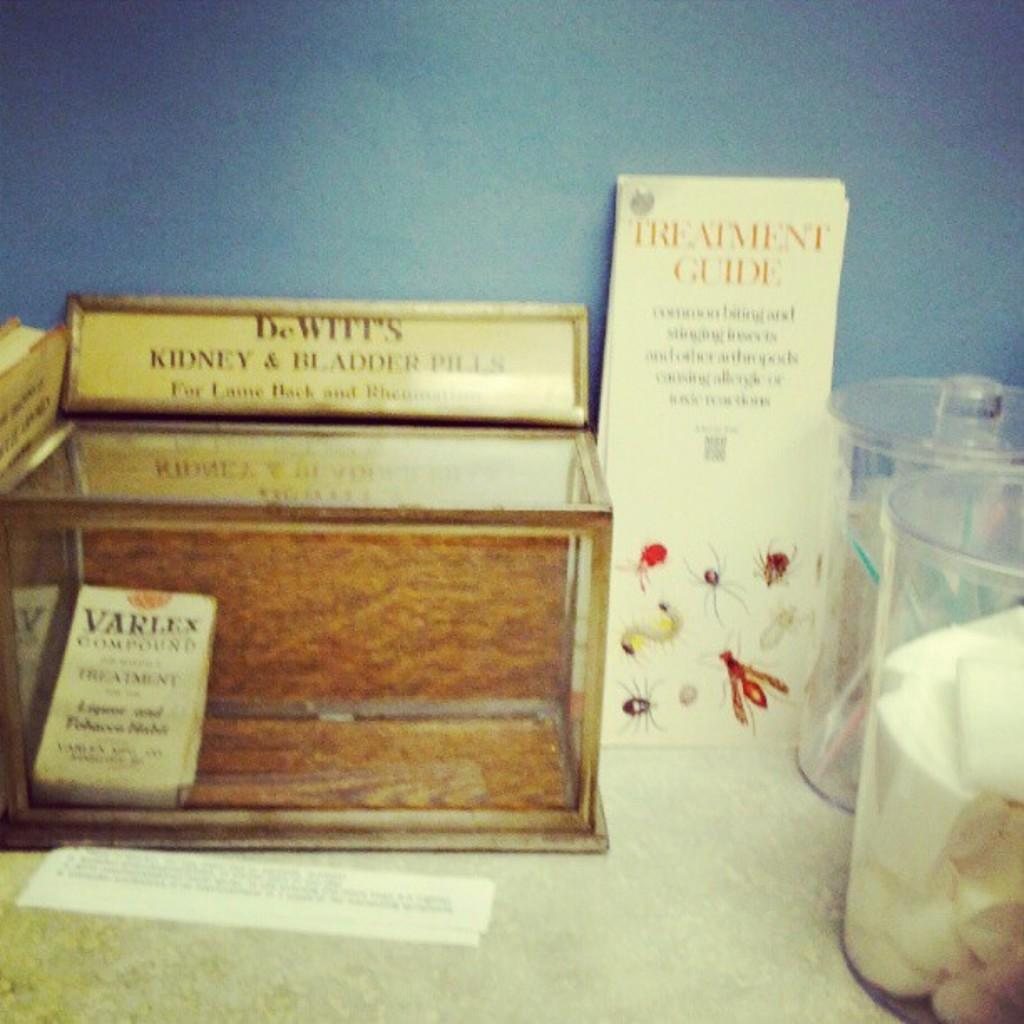<image>
Share a concise interpretation of the image provided. A table with medical supplies and a pamphlet that says Treatment Guide. 